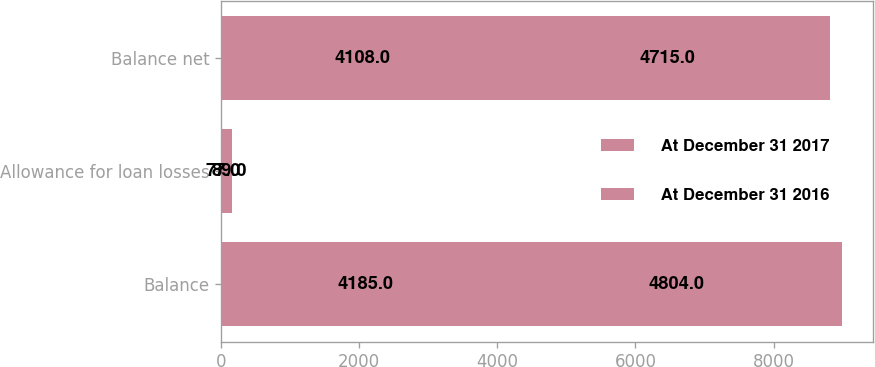Convert chart to OTSL. <chart><loc_0><loc_0><loc_500><loc_500><stacked_bar_chart><ecel><fcel>Balance<fcel>Allowance for loan losses<fcel>Balance net<nl><fcel>At December 31 2017<fcel>4185<fcel>77<fcel>4108<nl><fcel>At December 31 2016<fcel>4804<fcel>89<fcel>4715<nl></chart> 